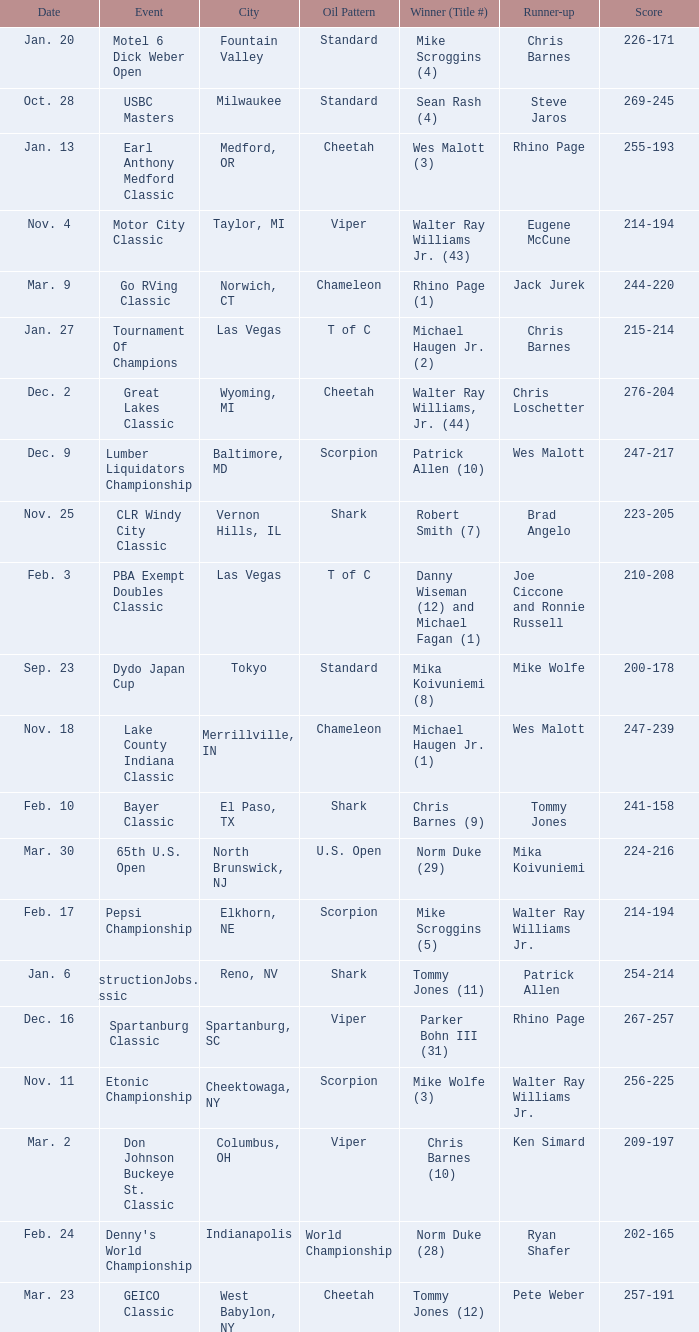Identify the date when robert smith (7) occurred? Nov. 25. 